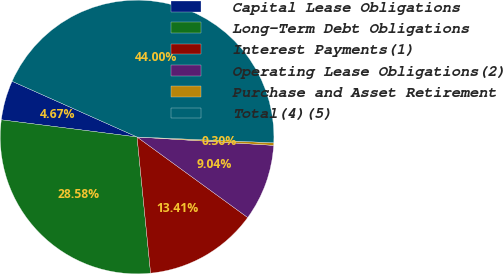Convert chart. <chart><loc_0><loc_0><loc_500><loc_500><pie_chart><fcel>Capital Lease Obligations<fcel>Long-Term Debt Obligations<fcel>Interest Payments(1)<fcel>Operating Lease Obligations(2)<fcel>Purchase and Asset Retirement<fcel>Total(4)(5)<nl><fcel>4.67%<fcel>28.58%<fcel>13.41%<fcel>9.04%<fcel>0.3%<fcel>44.0%<nl></chart> 